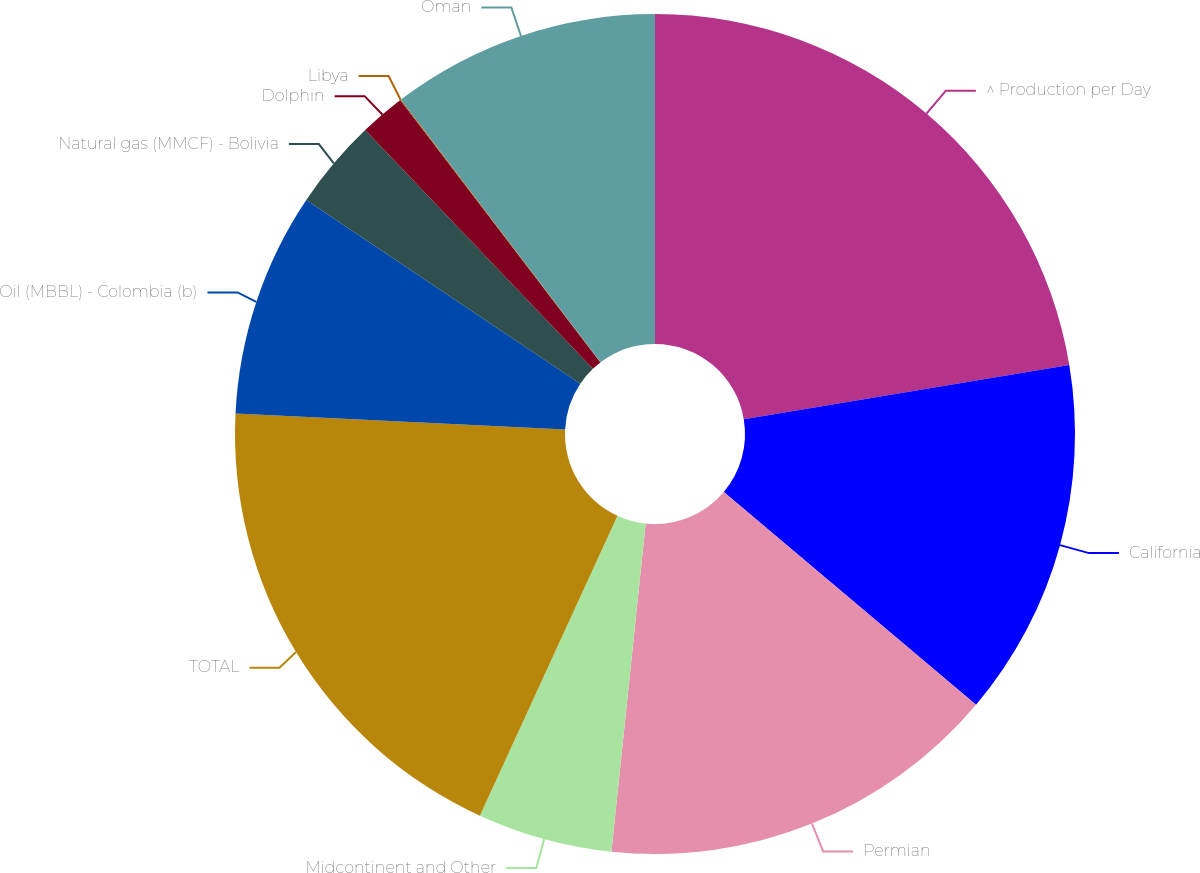<chart> <loc_0><loc_0><loc_500><loc_500><pie_chart><fcel>^ Production per Day<fcel>California<fcel>Permian<fcel>Midcontinent and Other<fcel>TOTAL<fcel>Oil (MBBL) - Colombia (b)<fcel>Natural gas (MMCF) - Bolivia<fcel>Dolphin<fcel>Libya<fcel>Oman<nl><fcel>22.37%<fcel>13.78%<fcel>15.5%<fcel>5.19%<fcel>18.93%<fcel>8.63%<fcel>3.47%<fcel>1.75%<fcel>0.03%<fcel>10.34%<nl></chart> 